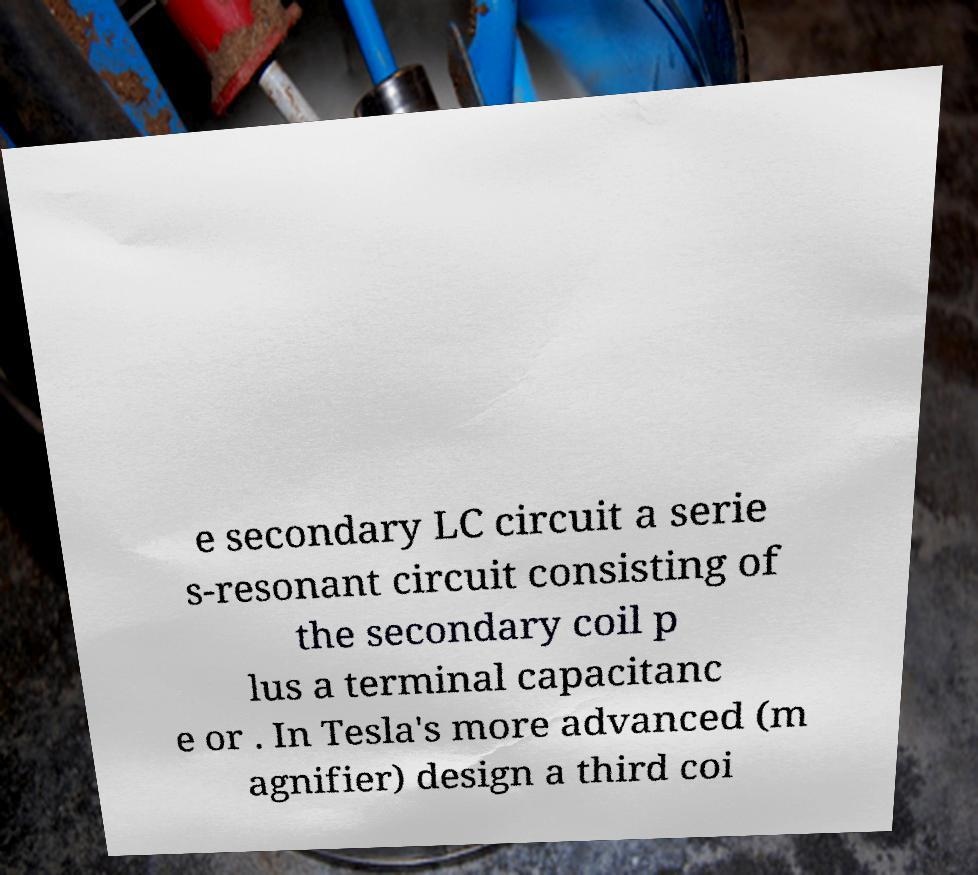Please read and relay the text visible in this image. What does it say? e secondary LC circuit a serie s-resonant circuit consisting of the secondary coil p lus a terminal capacitanc e or . In Tesla's more advanced (m agnifier) design a third coi 